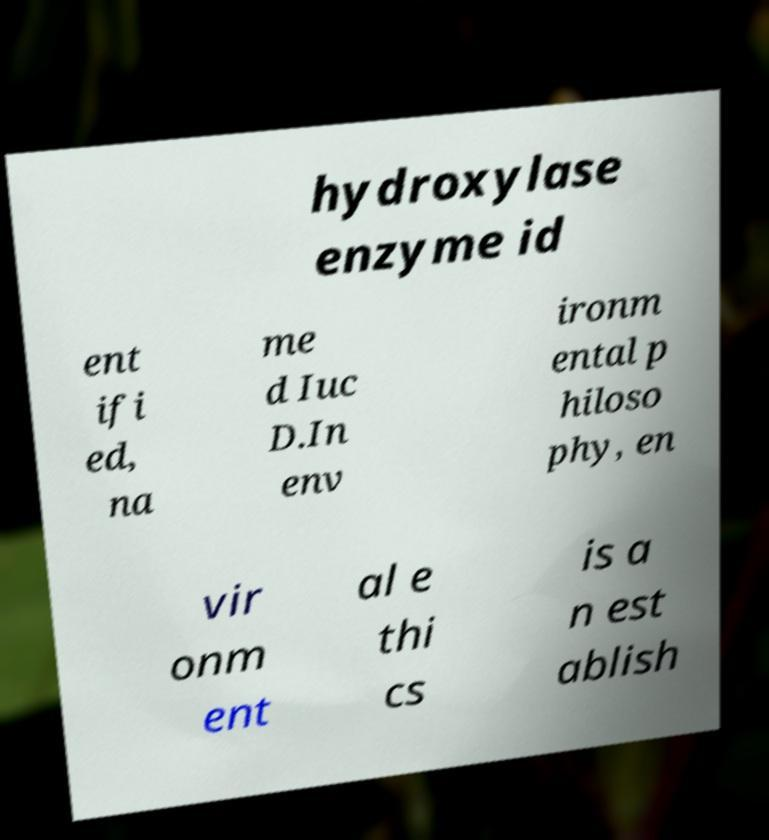Please read and relay the text visible in this image. What does it say? hydroxylase enzyme id ent ifi ed, na me d Iuc D.In env ironm ental p hiloso phy, en vir onm ent al e thi cs is a n est ablish 